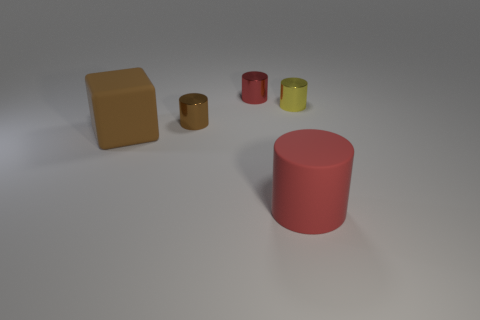How many other things are the same color as the block?
Offer a very short reply. 1. Is there a yellow thing that has the same material as the brown cylinder?
Give a very brief answer. Yes. What number of things are either brown blocks that are left of the red metallic cylinder or big red cylinders?
Provide a succinct answer. 2. Is there a small green metallic cylinder?
Offer a terse response. No. There is a object that is both right of the red metal object and behind the red rubber cylinder; what shape is it?
Your answer should be very brief. Cylinder. There is a red matte object right of the rubber block; what size is it?
Offer a very short reply. Large. There is a cylinder that is left of the tiny red cylinder; is its color the same as the matte cube?
Provide a succinct answer. Yes. How many tiny red objects have the same shape as the tiny brown metallic object?
Make the answer very short. 1. How many objects are either red things that are in front of the matte cube or objects to the left of the rubber cylinder?
Give a very brief answer. 4. How many red objects are either rubber cylinders or cylinders?
Offer a very short reply. 2. 